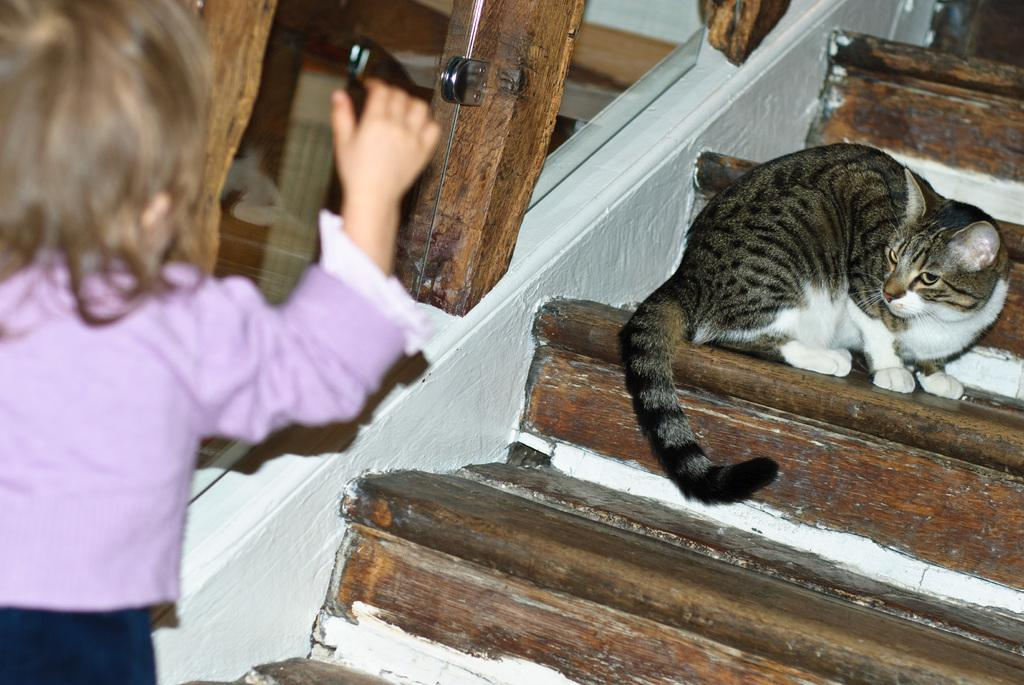What type of stairs are visible in the image? There are wooden stairs in the image. What animal can be seen in the image? There is a cat in the image. What is the background of the image made of? There is a wall in the image. Where is the girl located in the image? The girl is standing on the left side of the image. What type of rail can be seen on the stairs in the image? There is no rail present on the wooden stairs in the image. What time of day is depicted in the image? The time of day is not mentioned in the provided facts, so it cannot be determined from the image. 